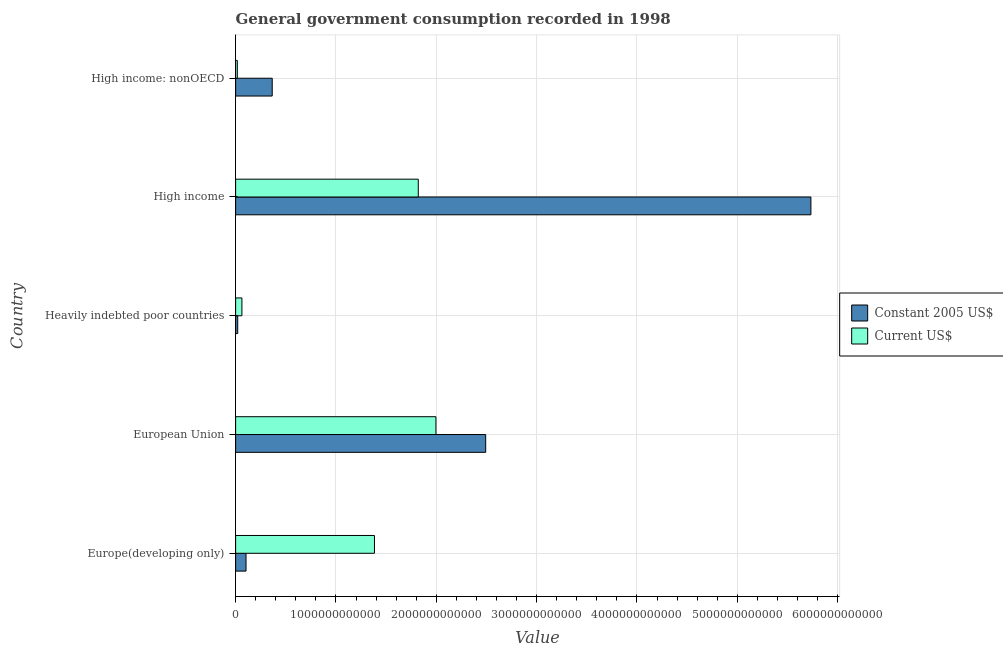How many groups of bars are there?
Provide a succinct answer. 5. How many bars are there on the 3rd tick from the top?
Make the answer very short. 2. How many bars are there on the 4th tick from the bottom?
Your answer should be compact. 2. What is the label of the 5th group of bars from the top?
Ensure brevity in your answer.  Europe(developing only). In how many cases, is the number of bars for a given country not equal to the number of legend labels?
Offer a terse response. 0. What is the value consumed in constant 2005 us$ in High income?
Your response must be concise. 5.73e+12. Across all countries, what is the maximum value consumed in current us$?
Your answer should be very brief. 2.00e+12. Across all countries, what is the minimum value consumed in constant 2005 us$?
Offer a terse response. 2.10e+1. In which country was the value consumed in current us$ minimum?
Your answer should be very brief. High income: nonOECD. What is the total value consumed in constant 2005 us$ in the graph?
Your answer should be compact. 8.72e+12. What is the difference between the value consumed in constant 2005 us$ in European Union and that in High income: nonOECD?
Make the answer very short. 2.13e+12. What is the difference between the value consumed in current us$ in Europe(developing only) and the value consumed in constant 2005 us$ in European Union?
Provide a short and direct response. -1.11e+12. What is the average value consumed in constant 2005 us$ per country?
Make the answer very short. 1.74e+12. What is the difference between the value consumed in current us$ and value consumed in constant 2005 us$ in High income?
Your answer should be very brief. -3.91e+12. What is the ratio of the value consumed in current us$ in Heavily indebted poor countries to that in High income: nonOECD?
Your response must be concise. 3.71. Is the difference between the value consumed in constant 2005 us$ in European Union and High income: nonOECD greater than the difference between the value consumed in current us$ in European Union and High income: nonOECD?
Your answer should be compact. Yes. What is the difference between the highest and the second highest value consumed in current us$?
Make the answer very short. 1.76e+11. What is the difference between the highest and the lowest value consumed in current us$?
Your answer should be compact. 1.98e+12. What does the 1st bar from the top in Europe(developing only) represents?
Give a very brief answer. Current US$. What does the 2nd bar from the bottom in Europe(developing only) represents?
Keep it short and to the point. Current US$. How many countries are there in the graph?
Your answer should be very brief. 5. What is the difference between two consecutive major ticks on the X-axis?
Provide a short and direct response. 1.00e+12. Does the graph contain any zero values?
Your answer should be very brief. No. Does the graph contain grids?
Ensure brevity in your answer.  Yes. Where does the legend appear in the graph?
Offer a terse response. Center right. How are the legend labels stacked?
Your answer should be compact. Vertical. What is the title of the graph?
Make the answer very short. General government consumption recorded in 1998. Does "Investment" appear as one of the legend labels in the graph?
Your answer should be very brief. No. What is the label or title of the X-axis?
Your answer should be very brief. Value. What is the Value of Constant 2005 US$ in Europe(developing only)?
Ensure brevity in your answer.  1.04e+11. What is the Value of Current US$ in Europe(developing only)?
Your answer should be compact. 1.38e+12. What is the Value in Constant 2005 US$ in European Union?
Give a very brief answer. 2.49e+12. What is the Value in Current US$ in European Union?
Offer a very short reply. 2.00e+12. What is the Value in Constant 2005 US$ in Heavily indebted poor countries?
Offer a terse response. 2.10e+1. What is the Value in Current US$ in Heavily indebted poor countries?
Ensure brevity in your answer.  6.28e+1. What is the Value of Constant 2005 US$ in High income?
Your response must be concise. 5.73e+12. What is the Value of Current US$ in High income?
Your answer should be compact. 1.82e+12. What is the Value of Constant 2005 US$ in High income: nonOECD?
Your answer should be compact. 3.65e+11. What is the Value in Current US$ in High income: nonOECD?
Your response must be concise. 1.69e+1. Across all countries, what is the maximum Value in Constant 2005 US$?
Offer a very short reply. 5.73e+12. Across all countries, what is the maximum Value in Current US$?
Offer a very short reply. 2.00e+12. Across all countries, what is the minimum Value of Constant 2005 US$?
Offer a terse response. 2.10e+1. Across all countries, what is the minimum Value in Current US$?
Offer a terse response. 1.69e+1. What is the total Value of Constant 2005 US$ in the graph?
Offer a terse response. 8.72e+12. What is the total Value of Current US$ in the graph?
Make the answer very short. 5.28e+12. What is the difference between the Value of Constant 2005 US$ in Europe(developing only) and that in European Union?
Give a very brief answer. -2.39e+12. What is the difference between the Value in Current US$ in Europe(developing only) and that in European Union?
Provide a succinct answer. -6.13e+11. What is the difference between the Value in Constant 2005 US$ in Europe(developing only) and that in Heavily indebted poor countries?
Your answer should be compact. 8.28e+1. What is the difference between the Value in Current US$ in Europe(developing only) and that in Heavily indebted poor countries?
Ensure brevity in your answer.  1.32e+12. What is the difference between the Value of Constant 2005 US$ in Europe(developing only) and that in High income?
Keep it short and to the point. -5.63e+12. What is the difference between the Value of Current US$ in Europe(developing only) and that in High income?
Your response must be concise. -4.37e+11. What is the difference between the Value in Constant 2005 US$ in Europe(developing only) and that in High income: nonOECD?
Your response must be concise. -2.61e+11. What is the difference between the Value of Current US$ in Europe(developing only) and that in High income: nonOECD?
Ensure brevity in your answer.  1.37e+12. What is the difference between the Value of Constant 2005 US$ in European Union and that in Heavily indebted poor countries?
Offer a very short reply. 2.47e+12. What is the difference between the Value of Current US$ in European Union and that in Heavily indebted poor countries?
Give a very brief answer. 1.93e+12. What is the difference between the Value of Constant 2005 US$ in European Union and that in High income?
Your response must be concise. -3.24e+12. What is the difference between the Value in Current US$ in European Union and that in High income?
Provide a succinct answer. 1.76e+11. What is the difference between the Value of Constant 2005 US$ in European Union and that in High income: nonOECD?
Offer a terse response. 2.13e+12. What is the difference between the Value in Current US$ in European Union and that in High income: nonOECD?
Offer a terse response. 1.98e+12. What is the difference between the Value of Constant 2005 US$ in Heavily indebted poor countries and that in High income?
Provide a short and direct response. -5.71e+12. What is the difference between the Value of Current US$ in Heavily indebted poor countries and that in High income?
Keep it short and to the point. -1.76e+12. What is the difference between the Value of Constant 2005 US$ in Heavily indebted poor countries and that in High income: nonOECD?
Provide a succinct answer. -3.44e+11. What is the difference between the Value in Current US$ in Heavily indebted poor countries and that in High income: nonOECD?
Your answer should be compact. 4.59e+1. What is the difference between the Value of Constant 2005 US$ in High income and that in High income: nonOECD?
Offer a very short reply. 5.37e+12. What is the difference between the Value of Current US$ in High income and that in High income: nonOECD?
Offer a terse response. 1.80e+12. What is the difference between the Value of Constant 2005 US$ in Europe(developing only) and the Value of Current US$ in European Union?
Provide a succinct answer. -1.89e+12. What is the difference between the Value in Constant 2005 US$ in Europe(developing only) and the Value in Current US$ in Heavily indebted poor countries?
Provide a succinct answer. 4.10e+1. What is the difference between the Value in Constant 2005 US$ in Europe(developing only) and the Value in Current US$ in High income?
Your answer should be compact. -1.72e+12. What is the difference between the Value of Constant 2005 US$ in Europe(developing only) and the Value of Current US$ in High income: nonOECD?
Provide a short and direct response. 8.69e+1. What is the difference between the Value of Constant 2005 US$ in European Union and the Value of Current US$ in Heavily indebted poor countries?
Provide a short and direct response. 2.43e+12. What is the difference between the Value in Constant 2005 US$ in European Union and the Value in Current US$ in High income?
Offer a terse response. 6.72e+11. What is the difference between the Value in Constant 2005 US$ in European Union and the Value in Current US$ in High income: nonOECD?
Provide a short and direct response. 2.48e+12. What is the difference between the Value of Constant 2005 US$ in Heavily indebted poor countries and the Value of Current US$ in High income?
Provide a short and direct response. -1.80e+12. What is the difference between the Value in Constant 2005 US$ in Heavily indebted poor countries and the Value in Current US$ in High income: nonOECD?
Offer a very short reply. 4.04e+09. What is the difference between the Value of Constant 2005 US$ in High income and the Value of Current US$ in High income: nonOECD?
Give a very brief answer. 5.72e+12. What is the average Value in Constant 2005 US$ per country?
Provide a succinct answer. 1.74e+12. What is the average Value in Current US$ per country?
Ensure brevity in your answer.  1.06e+12. What is the difference between the Value of Constant 2005 US$ and Value of Current US$ in Europe(developing only)?
Ensure brevity in your answer.  -1.28e+12. What is the difference between the Value in Constant 2005 US$ and Value in Current US$ in European Union?
Keep it short and to the point. 4.96e+11. What is the difference between the Value of Constant 2005 US$ and Value of Current US$ in Heavily indebted poor countries?
Your response must be concise. -4.18e+1. What is the difference between the Value in Constant 2005 US$ and Value in Current US$ in High income?
Offer a very short reply. 3.91e+12. What is the difference between the Value in Constant 2005 US$ and Value in Current US$ in High income: nonOECD?
Keep it short and to the point. 3.48e+11. What is the ratio of the Value in Constant 2005 US$ in Europe(developing only) to that in European Union?
Your answer should be very brief. 0.04. What is the ratio of the Value in Current US$ in Europe(developing only) to that in European Union?
Offer a terse response. 0.69. What is the ratio of the Value in Constant 2005 US$ in Europe(developing only) to that in Heavily indebted poor countries?
Ensure brevity in your answer.  4.95. What is the ratio of the Value of Current US$ in Europe(developing only) to that in Heavily indebted poor countries?
Give a very brief answer. 22.04. What is the ratio of the Value of Constant 2005 US$ in Europe(developing only) to that in High income?
Give a very brief answer. 0.02. What is the ratio of the Value of Current US$ in Europe(developing only) to that in High income?
Give a very brief answer. 0.76. What is the ratio of the Value in Constant 2005 US$ in Europe(developing only) to that in High income: nonOECD?
Your response must be concise. 0.28. What is the ratio of the Value in Current US$ in Europe(developing only) to that in High income: nonOECD?
Keep it short and to the point. 81.74. What is the ratio of the Value of Constant 2005 US$ in European Union to that in Heavily indebted poor countries?
Ensure brevity in your answer.  118.87. What is the ratio of the Value of Current US$ in European Union to that in Heavily indebted poor countries?
Your answer should be very brief. 31.8. What is the ratio of the Value of Constant 2005 US$ in European Union to that in High income?
Ensure brevity in your answer.  0.43. What is the ratio of the Value in Current US$ in European Union to that in High income?
Your answer should be very brief. 1.1. What is the ratio of the Value in Constant 2005 US$ in European Union to that in High income: nonOECD?
Provide a short and direct response. 6.83. What is the ratio of the Value of Current US$ in European Union to that in High income: nonOECD?
Give a very brief answer. 117.93. What is the ratio of the Value of Constant 2005 US$ in Heavily indebted poor countries to that in High income?
Provide a succinct answer. 0. What is the ratio of the Value in Current US$ in Heavily indebted poor countries to that in High income?
Keep it short and to the point. 0.03. What is the ratio of the Value in Constant 2005 US$ in Heavily indebted poor countries to that in High income: nonOECD?
Keep it short and to the point. 0.06. What is the ratio of the Value in Current US$ in Heavily indebted poor countries to that in High income: nonOECD?
Your answer should be very brief. 3.71. What is the ratio of the Value of Constant 2005 US$ in High income to that in High income: nonOECD?
Provide a succinct answer. 15.72. What is the ratio of the Value in Current US$ in High income to that in High income: nonOECD?
Provide a succinct answer. 107.53. What is the difference between the highest and the second highest Value in Constant 2005 US$?
Your response must be concise. 3.24e+12. What is the difference between the highest and the second highest Value of Current US$?
Your answer should be compact. 1.76e+11. What is the difference between the highest and the lowest Value in Constant 2005 US$?
Give a very brief answer. 5.71e+12. What is the difference between the highest and the lowest Value of Current US$?
Keep it short and to the point. 1.98e+12. 